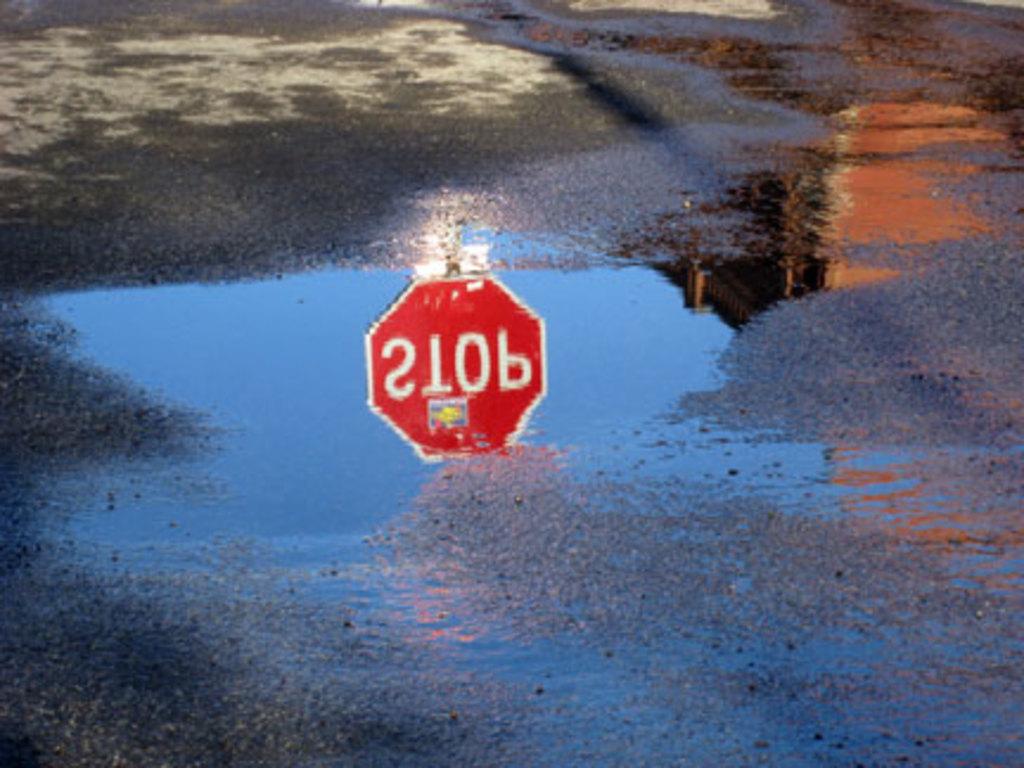The letters are backwards, what does the sign say?
Offer a very short reply. Stop. What should you do at this sign?
Give a very brief answer. Stop. 